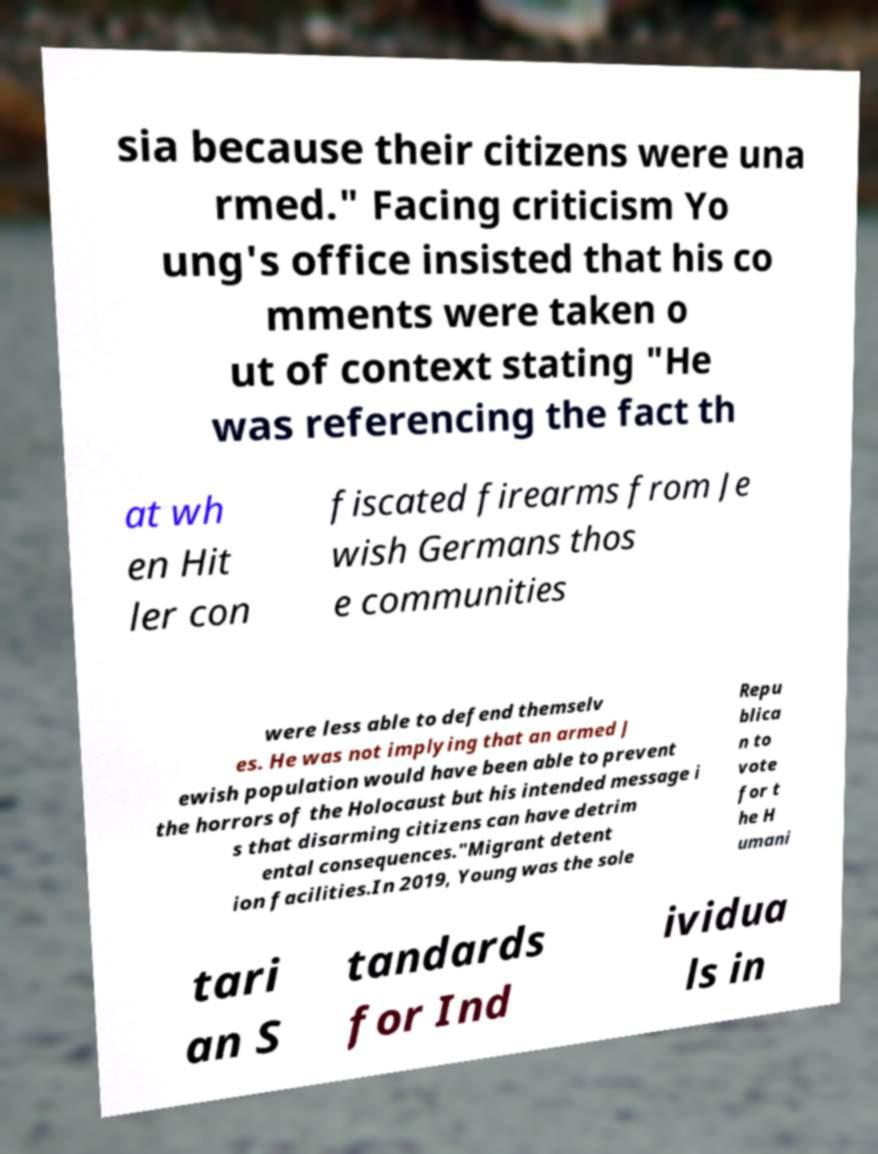Please identify and transcribe the text found in this image. sia because their citizens were una rmed." Facing criticism Yo ung's office insisted that his co mments were taken o ut of context stating "He was referencing the fact th at wh en Hit ler con fiscated firearms from Je wish Germans thos e communities were less able to defend themselv es. He was not implying that an armed J ewish population would have been able to prevent the horrors of the Holocaust but his intended message i s that disarming citizens can have detrim ental consequences."Migrant detent ion facilities.In 2019, Young was the sole Repu blica n to vote for t he H umani tari an S tandards for Ind ividua ls in 